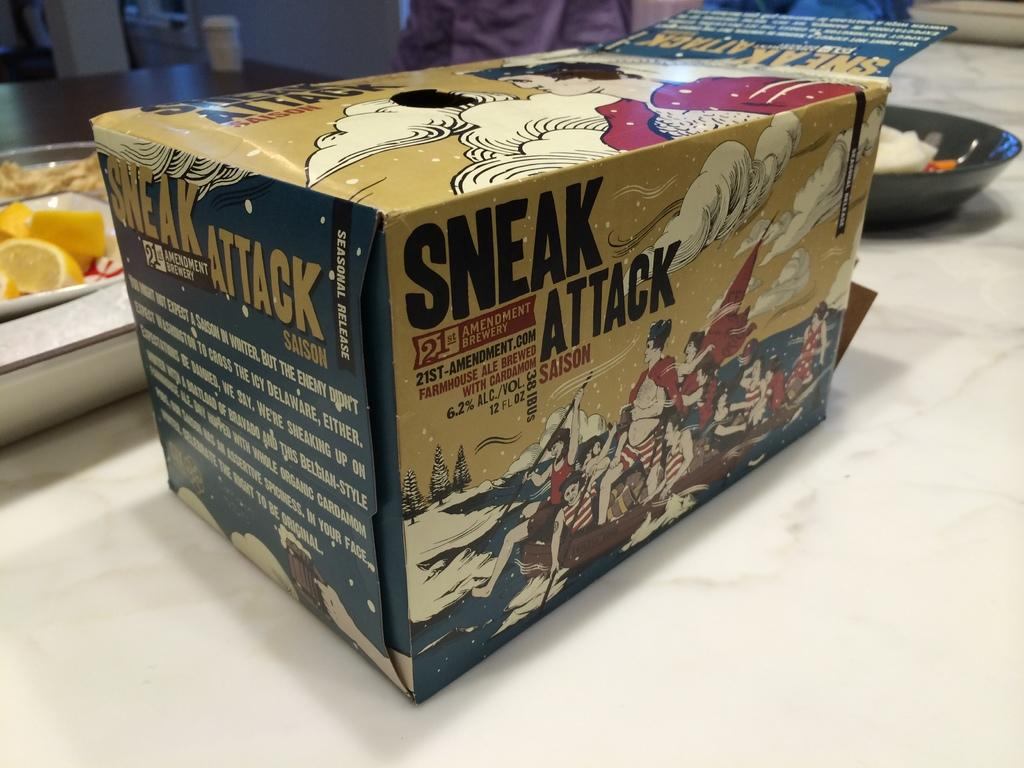Provide a one-sentence caption for the provided image. a box with the words sneak attack on it on a table. 